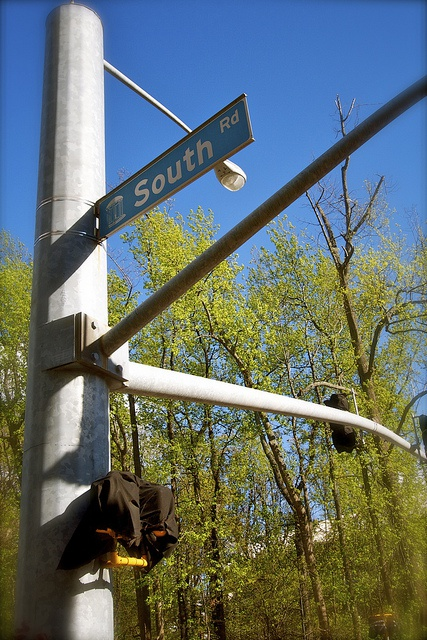Describe the objects in this image and their specific colors. I can see traffic light in navy, black, gray, and maroon tones, traffic light in navy, black, maroon, and olive tones, and traffic light in navy, black, olive, and gray tones in this image. 